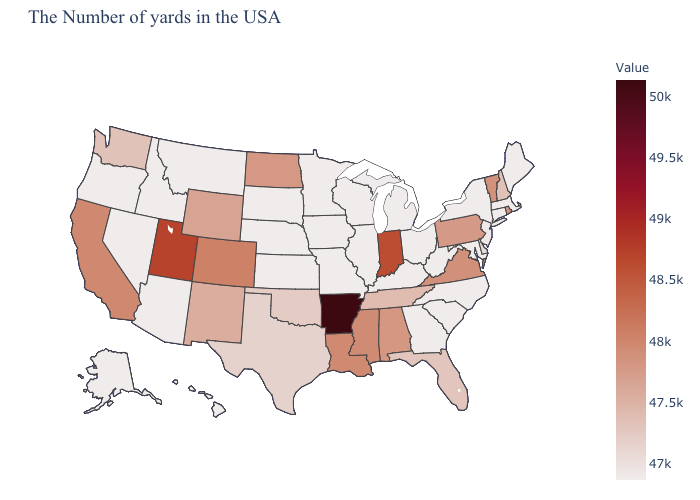Is the legend a continuous bar?
Keep it brief. Yes. Among the states that border Maryland , does West Virginia have the lowest value?
Write a very short answer. Yes. Does the map have missing data?
Keep it brief. No. Which states have the lowest value in the USA?
Write a very short answer. Maine, Connecticut, New York, Maryland, North Carolina, South Carolina, West Virginia, Ohio, Georgia, Michigan, Kentucky, Wisconsin, Illinois, Missouri, Minnesota, Iowa, Kansas, Nebraska, South Dakota, Montana, Arizona, Idaho, Nevada, Oregon, Alaska, Hawaii. Among the states that border Ohio , does Indiana have the highest value?
Be succinct. Yes. 